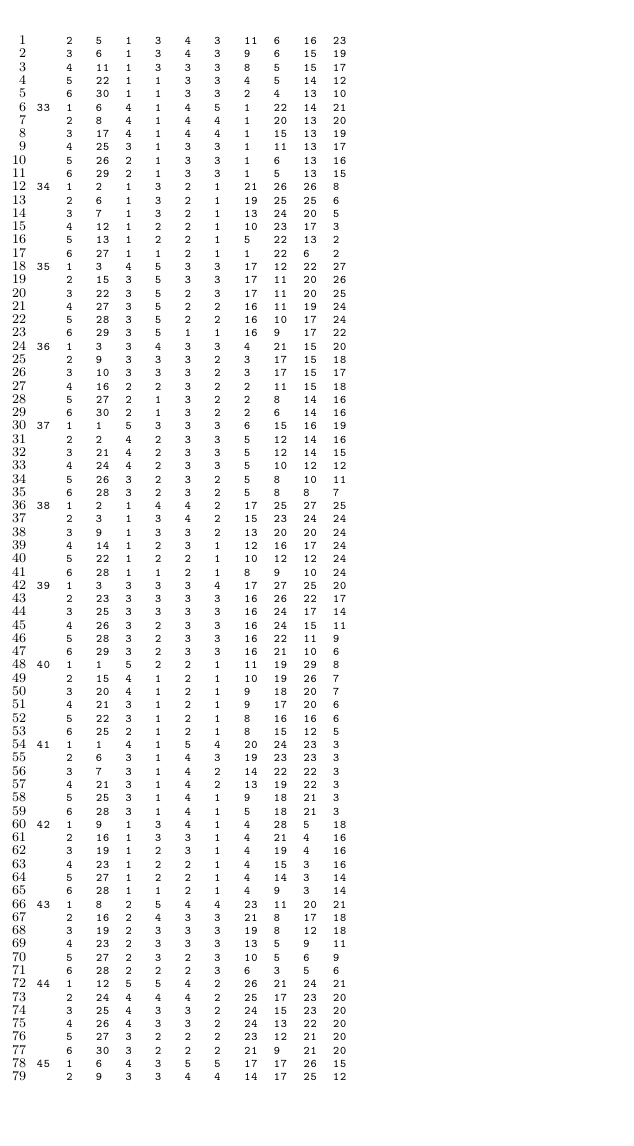Convert code to text. <code><loc_0><loc_0><loc_500><loc_500><_ObjectiveC_>	2	5	1	3	4	3	11	6	16	23	
	3	6	1	3	4	3	9	6	15	19	
	4	11	1	3	3	3	8	5	15	17	
	5	22	1	1	3	3	4	5	14	12	
	6	30	1	1	3	3	2	4	13	10	
33	1	6	4	1	4	5	1	22	14	21	
	2	8	4	1	4	4	1	20	13	20	
	3	17	4	1	4	4	1	15	13	19	
	4	25	3	1	3	3	1	11	13	17	
	5	26	2	1	3	3	1	6	13	16	
	6	29	2	1	3	3	1	5	13	15	
34	1	2	1	3	2	1	21	26	26	8	
	2	6	1	3	2	1	19	25	25	6	
	3	7	1	3	2	1	13	24	20	5	
	4	12	1	2	2	1	10	23	17	3	
	5	13	1	2	2	1	5	22	13	2	
	6	27	1	1	2	1	1	22	6	2	
35	1	3	4	5	3	3	17	12	22	27	
	2	15	3	5	3	3	17	11	20	26	
	3	22	3	5	2	3	17	11	20	25	
	4	27	3	5	2	2	16	11	19	24	
	5	28	3	5	2	2	16	10	17	24	
	6	29	3	5	1	1	16	9	17	22	
36	1	3	3	4	3	3	4	21	15	20	
	2	9	3	3	3	2	3	17	15	18	
	3	10	3	3	3	2	3	17	15	17	
	4	16	2	2	3	2	2	11	15	18	
	5	27	2	1	3	2	2	8	14	16	
	6	30	2	1	3	2	2	6	14	16	
37	1	1	5	3	3	3	6	15	16	19	
	2	2	4	2	3	3	5	12	14	16	
	3	21	4	2	3	3	5	12	14	15	
	4	24	4	2	3	3	5	10	12	12	
	5	26	3	2	3	2	5	8	10	11	
	6	28	3	2	3	2	5	8	8	7	
38	1	2	1	4	4	2	17	25	27	25	
	2	3	1	3	4	2	15	23	24	24	
	3	9	1	3	3	2	13	20	20	24	
	4	14	1	2	3	1	12	16	17	24	
	5	22	1	2	2	1	10	12	12	24	
	6	28	1	1	2	1	8	9	10	24	
39	1	3	3	3	3	4	17	27	25	20	
	2	23	3	3	3	3	16	26	22	17	
	3	25	3	3	3	3	16	24	17	14	
	4	26	3	2	3	3	16	24	15	11	
	5	28	3	2	3	3	16	22	11	9	
	6	29	3	2	3	3	16	21	10	6	
40	1	1	5	2	2	1	11	19	29	8	
	2	15	4	1	2	1	10	19	26	7	
	3	20	4	1	2	1	9	18	20	7	
	4	21	3	1	2	1	9	17	20	6	
	5	22	3	1	2	1	8	16	16	6	
	6	25	2	1	2	1	8	15	12	5	
41	1	1	4	1	5	4	20	24	23	3	
	2	6	3	1	4	3	19	23	23	3	
	3	7	3	1	4	2	14	22	22	3	
	4	21	3	1	4	2	13	19	22	3	
	5	25	3	1	4	1	9	18	21	3	
	6	28	3	1	4	1	5	18	21	3	
42	1	9	1	3	4	1	4	28	5	18	
	2	16	1	3	3	1	4	21	4	16	
	3	19	1	2	3	1	4	19	4	16	
	4	23	1	2	2	1	4	15	3	16	
	5	27	1	2	2	1	4	14	3	14	
	6	28	1	1	2	1	4	9	3	14	
43	1	8	2	5	4	4	23	11	20	21	
	2	16	2	4	3	3	21	8	17	18	
	3	19	2	3	3	3	19	8	12	18	
	4	23	2	3	3	3	13	5	9	11	
	5	27	2	3	2	3	10	5	6	9	
	6	28	2	2	2	3	6	3	5	6	
44	1	12	5	5	4	2	26	21	24	21	
	2	24	4	4	4	2	25	17	23	20	
	3	25	4	3	3	2	24	15	23	20	
	4	26	4	3	3	2	24	13	22	20	
	5	27	3	2	2	2	23	12	21	20	
	6	30	3	2	2	2	21	9	21	20	
45	1	6	4	3	5	5	17	17	26	15	
	2	9	3	3	4	4	14	17	25	12	</code> 